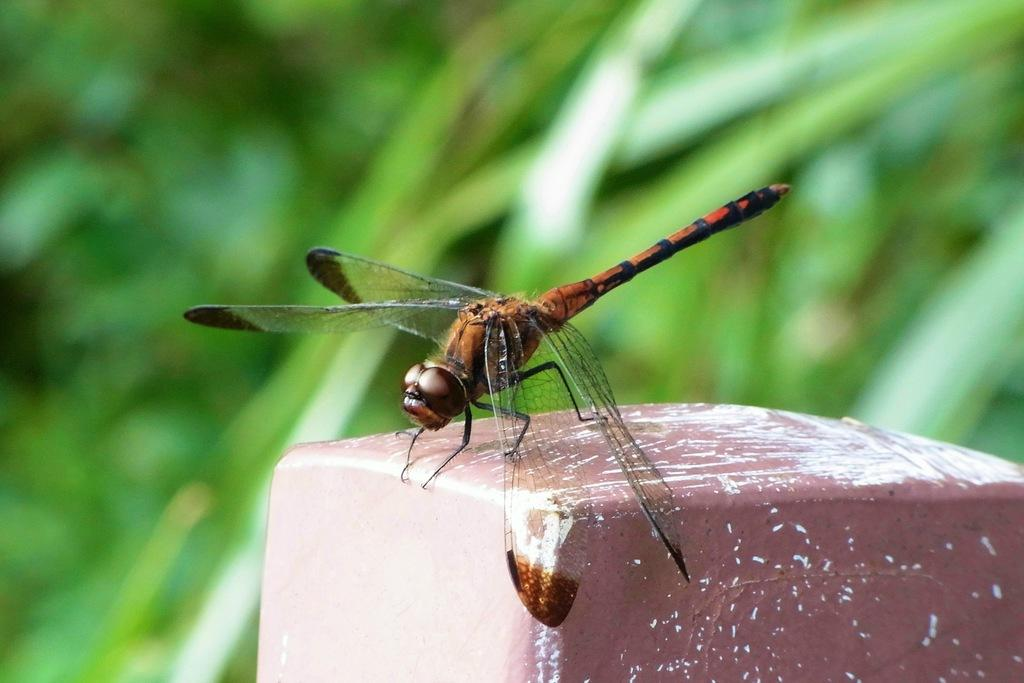What insect is present in the image? There is a dragonfly in the image. Where is the dragonfly located? The dragonfly is on the floor. Can you describe the background of the image? The background of the image is blurry. What type of smoke can be seen coming from the dragonfly's wings in the image? There is no smoke present in the image; it features a dragonfly on the floor with a blurry background. 